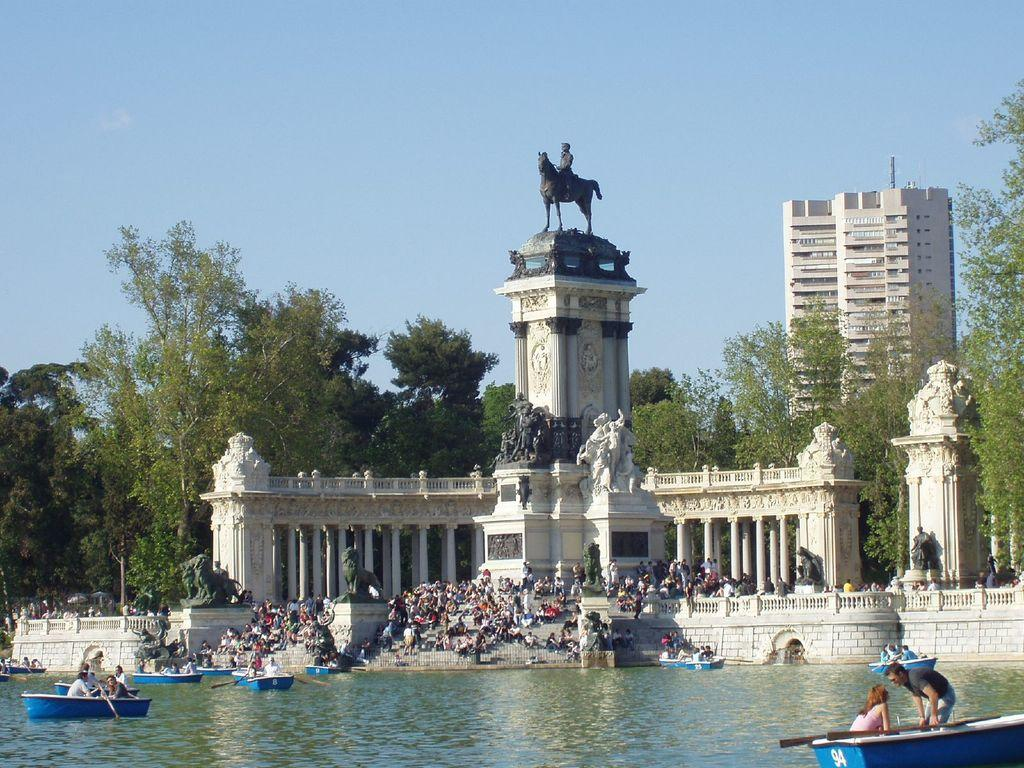What is on the water in the image? There are boats on the water in the image. Who or what is present in the image besides the boats? There is a group of people, sculptures, pillars, trees, and a building in the image. What can be seen in the background of the image? The sky is visible in the background of the image. What type of wire is being used to play the game in the image? There is no wire or game present in the image. How does the heat affect the people in the image? There is no indication of heat or its effects on the people in the image. 